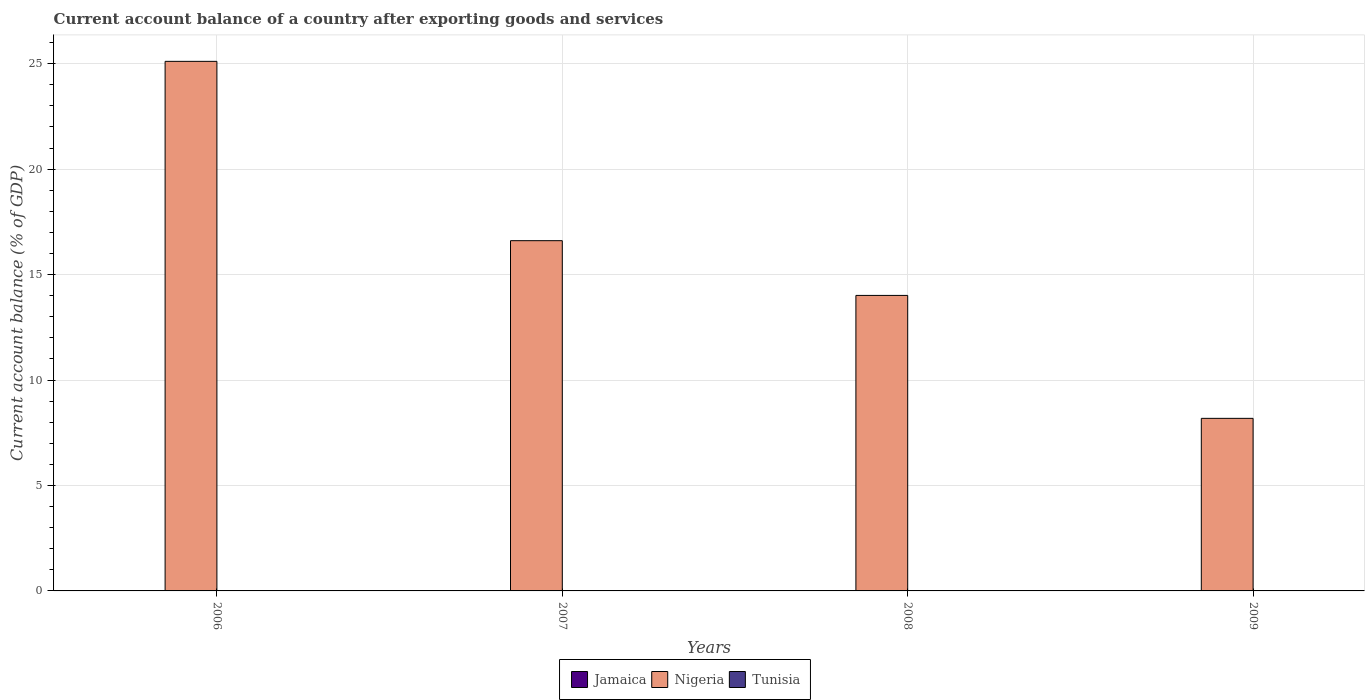How many different coloured bars are there?
Give a very brief answer. 1. Are the number of bars per tick equal to the number of legend labels?
Make the answer very short. No. How many bars are there on the 3rd tick from the left?
Offer a very short reply. 1. In how many cases, is the number of bars for a given year not equal to the number of legend labels?
Give a very brief answer. 4. What is the account balance in Jamaica in 2006?
Provide a short and direct response. 0. What is the difference between the account balance in Nigeria in 2006 and that in 2009?
Provide a short and direct response. 16.93. What is the difference between the account balance in Jamaica in 2007 and the account balance in Nigeria in 2006?
Offer a very short reply. -25.11. What is the ratio of the account balance in Nigeria in 2006 to that in 2007?
Your response must be concise. 1.51. Is the account balance in Nigeria in 2007 less than that in 2009?
Offer a terse response. No. What is the difference between the highest and the second highest account balance in Nigeria?
Keep it short and to the point. 8.5. What is the difference between the highest and the lowest account balance in Nigeria?
Your response must be concise. 16.93. Is the sum of the account balance in Nigeria in 2007 and 2009 greater than the maximum account balance in Jamaica across all years?
Keep it short and to the point. Yes. Is it the case that in every year, the sum of the account balance in Nigeria and account balance in Jamaica is greater than the account balance in Tunisia?
Provide a succinct answer. Yes. How many bars are there?
Your answer should be very brief. 4. Are all the bars in the graph horizontal?
Your answer should be compact. No. Are the values on the major ticks of Y-axis written in scientific E-notation?
Ensure brevity in your answer.  No. Does the graph contain grids?
Your response must be concise. Yes. What is the title of the graph?
Your answer should be compact. Current account balance of a country after exporting goods and services. Does "Moldova" appear as one of the legend labels in the graph?
Keep it short and to the point. No. What is the label or title of the X-axis?
Offer a very short reply. Years. What is the label or title of the Y-axis?
Offer a terse response. Current account balance (% of GDP). What is the Current account balance (% of GDP) in Nigeria in 2006?
Provide a short and direct response. 25.11. What is the Current account balance (% of GDP) of Jamaica in 2007?
Offer a terse response. 0. What is the Current account balance (% of GDP) in Nigeria in 2007?
Make the answer very short. 16.61. What is the Current account balance (% of GDP) of Jamaica in 2008?
Give a very brief answer. 0. What is the Current account balance (% of GDP) of Nigeria in 2008?
Provide a short and direct response. 14.01. What is the Current account balance (% of GDP) of Nigeria in 2009?
Your answer should be very brief. 8.18. What is the Current account balance (% of GDP) of Tunisia in 2009?
Offer a very short reply. 0. Across all years, what is the maximum Current account balance (% of GDP) of Nigeria?
Provide a short and direct response. 25.11. Across all years, what is the minimum Current account balance (% of GDP) in Nigeria?
Make the answer very short. 8.18. What is the total Current account balance (% of GDP) in Nigeria in the graph?
Your response must be concise. 63.91. What is the total Current account balance (% of GDP) of Tunisia in the graph?
Ensure brevity in your answer.  0. What is the difference between the Current account balance (% of GDP) of Nigeria in 2006 and that in 2007?
Your answer should be compact. 8.5. What is the difference between the Current account balance (% of GDP) in Nigeria in 2006 and that in 2008?
Offer a terse response. 11.1. What is the difference between the Current account balance (% of GDP) in Nigeria in 2006 and that in 2009?
Keep it short and to the point. 16.93. What is the difference between the Current account balance (% of GDP) in Nigeria in 2007 and that in 2008?
Your response must be concise. 2.6. What is the difference between the Current account balance (% of GDP) of Nigeria in 2007 and that in 2009?
Provide a short and direct response. 8.43. What is the difference between the Current account balance (% of GDP) in Nigeria in 2008 and that in 2009?
Provide a succinct answer. 5.83. What is the average Current account balance (% of GDP) of Jamaica per year?
Keep it short and to the point. 0. What is the average Current account balance (% of GDP) of Nigeria per year?
Your answer should be compact. 15.98. What is the average Current account balance (% of GDP) in Tunisia per year?
Your answer should be very brief. 0. What is the ratio of the Current account balance (% of GDP) of Nigeria in 2006 to that in 2007?
Keep it short and to the point. 1.51. What is the ratio of the Current account balance (% of GDP) in Nigeria in 2006 to that in 2008?
Make the answer very short. 1.79. What is the ratio of the Current account balance (% of GDP) in Nigeria in 2006 to that in 2009?
Offer a terse response. 3.07. What is the ratio of the Current account balance (% of GDP) of Nigeria in 2007 to that in 2008?
Your response must be concise. 1.19. What is the ratio of the Current account balance (% of GDP) in Nigeria in 2007 to that in 2009?
Make the answer very short. 2.03. What is the ratio of the Current account balance (% of GDP) in Nigeria in 2008 to that in 2009?
Your answer should be compact. 1.71. What is the difference between the highest and the second highest Current account balance (% of GDP) in Nigeria?
Give a very brief answer. 8.5. What is the difference between the highest and the lowest Current account balance (% of GDP) of Nigeria?
Your answer should be very brief. 16.93. 